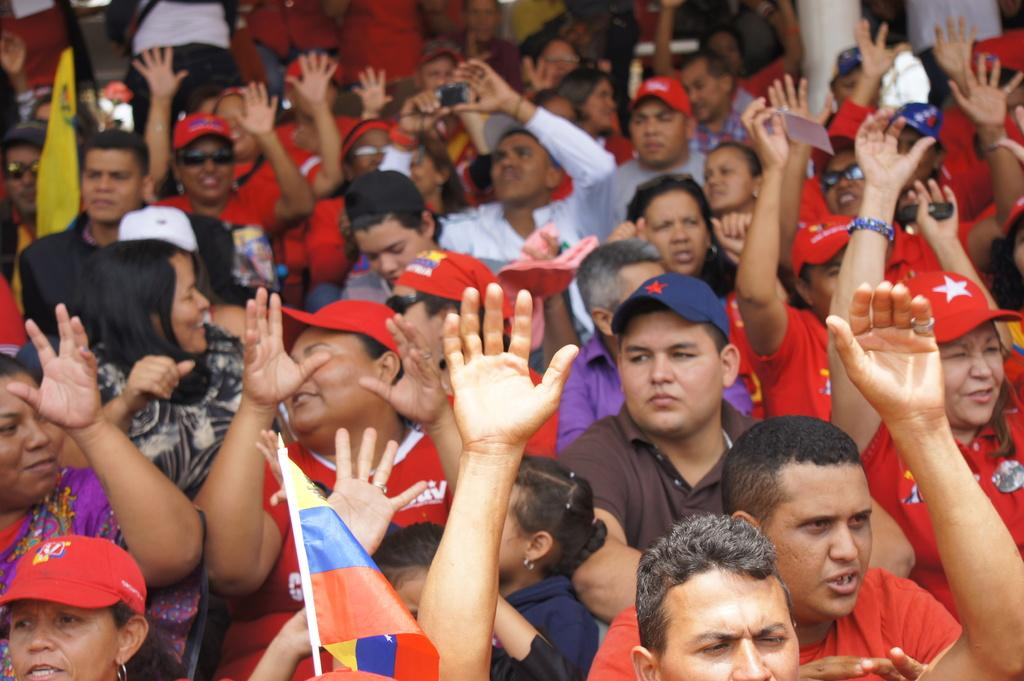What is the main subject of the image? The main subject of the image is a crowd. What are the people in the crowd holding? The people in the crowd are holding flags. Can you tell if the image was taken during the day or night? The image was likely taken during the day, as there is no indication of darkness or artificial lighting. Can you see any wounds or bones on the people in the image? There is no indication of wounds or bones on the people in the image; the focus is on the crowd and the flags they are holding. 